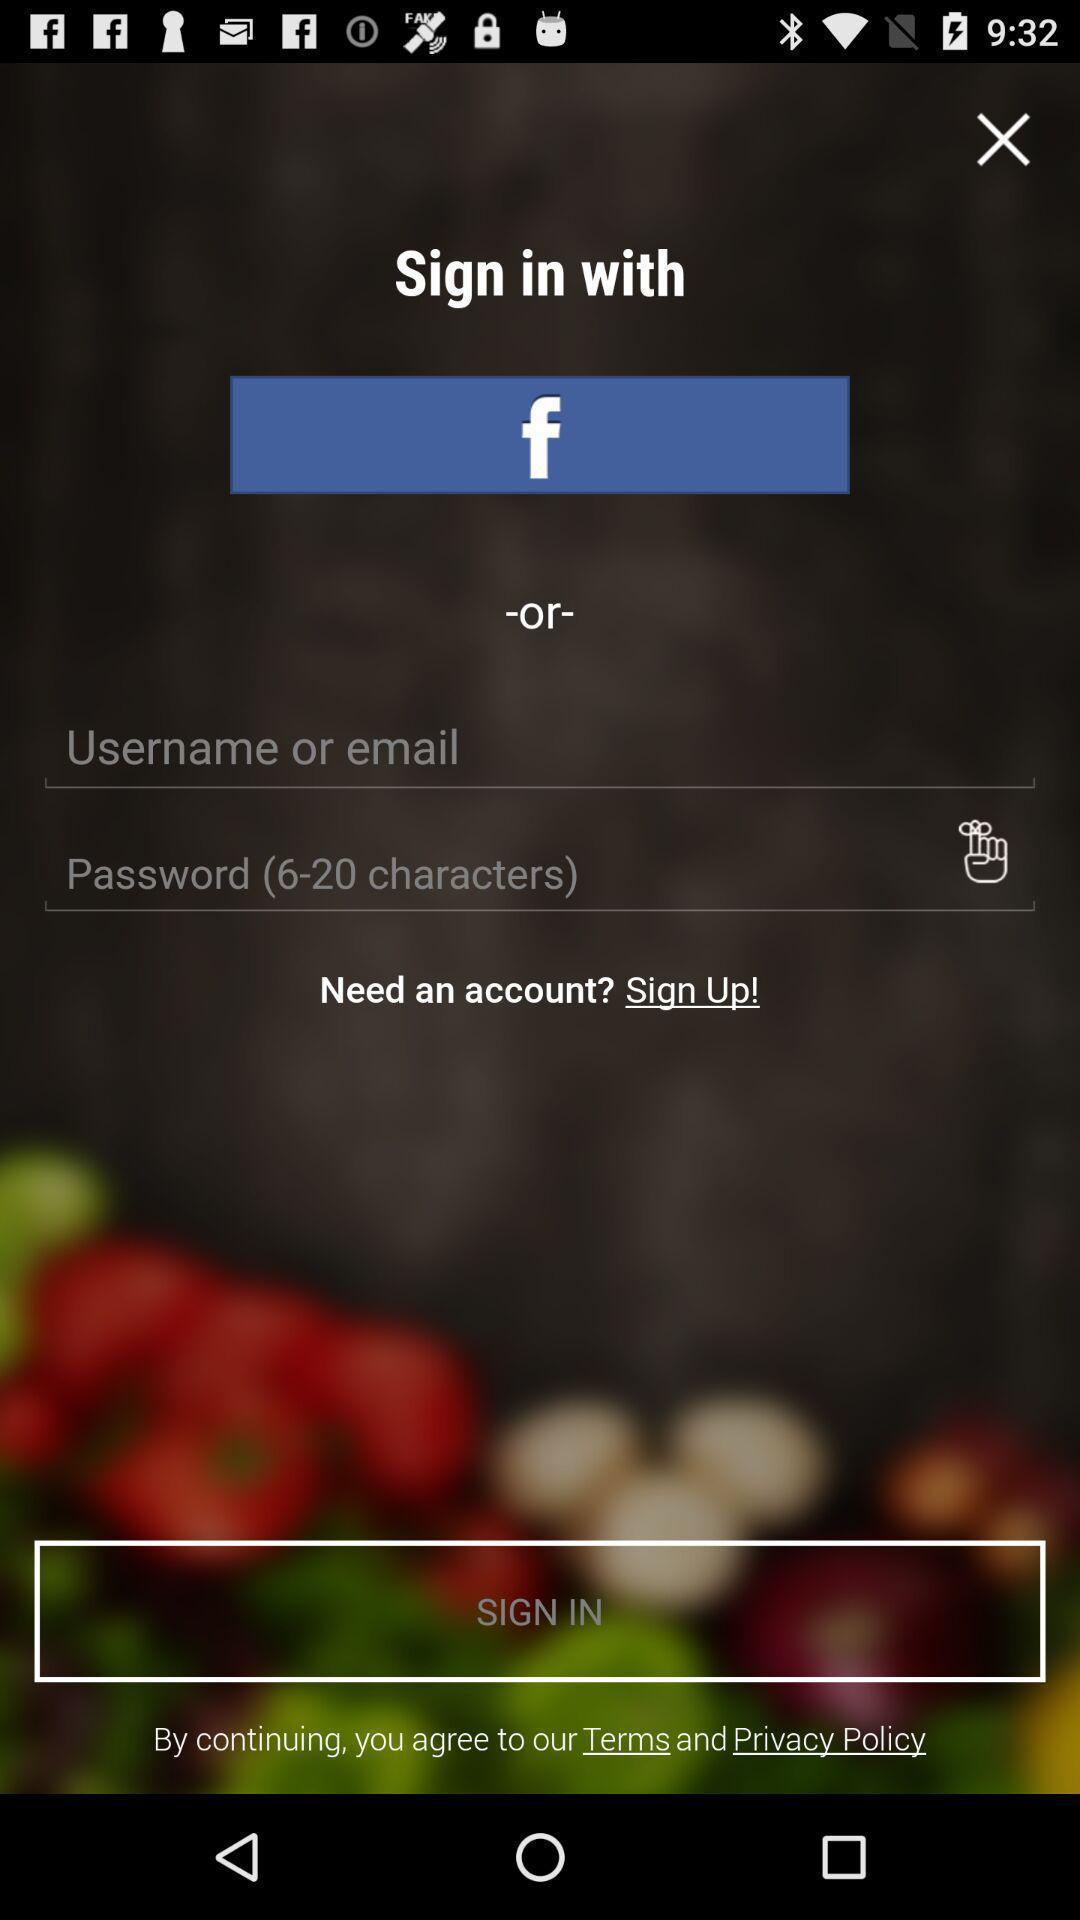Explain the elements present in this screenshot. Sign in page for social media application. 